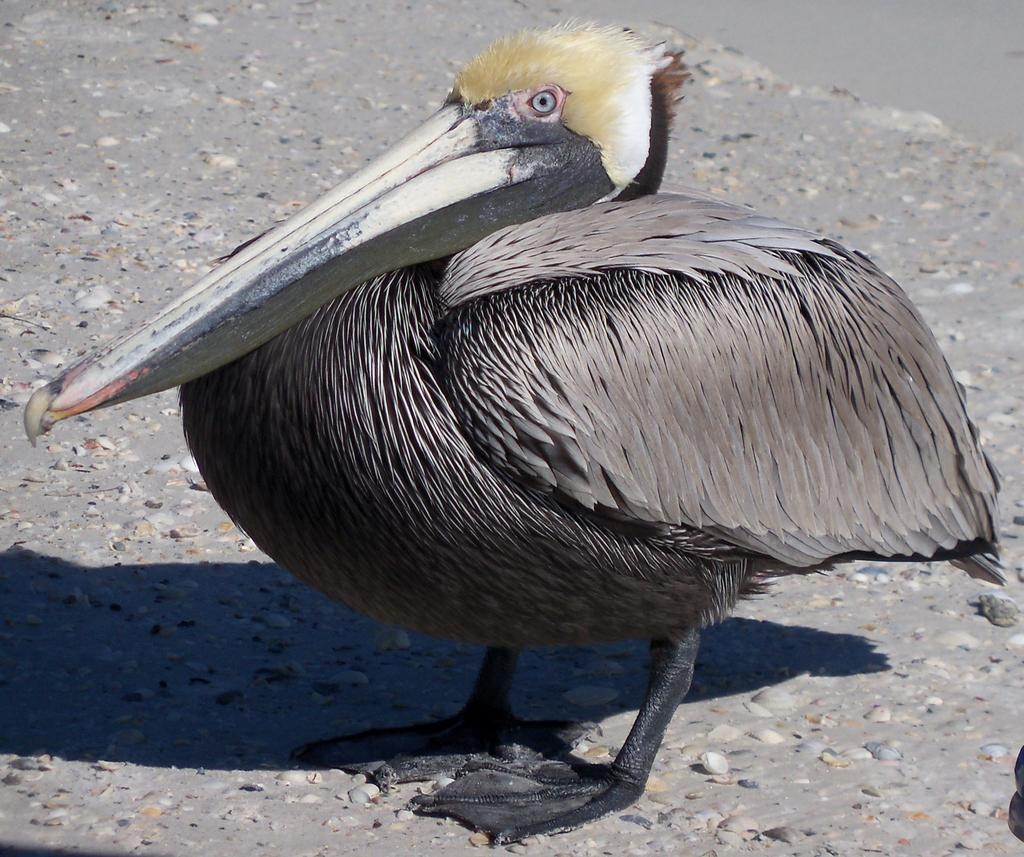What type of animal can be seen on the ground in the image? There is a bird on the ground in the image. What else can be seen on the ground in the image? There are stones visible in the image. What type of bushes can be seen growing near the bird in the image? There is no mention of bushes in the image; only a bird and stones are visible. What role does friction play in the bird's movement in the image? The image does not depict the bird in motion, so friction is not relevant to the bird's movement in the image. Can you describe the color of the orange in the image? There is no orange present in the image; only a bird and stones are visible. 